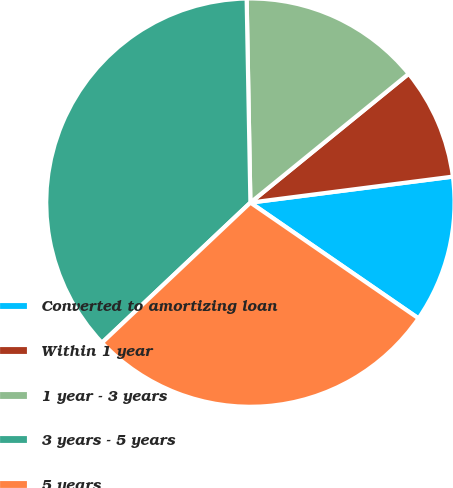<chart> <loc_0><loc_0><loc_500><loc_500><pie_chart><fcel>Converted to amortizing loan<fcel>Within 1 year<fcel>1 year - 3 years<fcel>3 years - 5 years<fcel>5 years<nl><fcel>11.63%<fcel>8.84%<fcel>14.42%<fcel>36.75%<fcel>28.36%<nl></chart> 